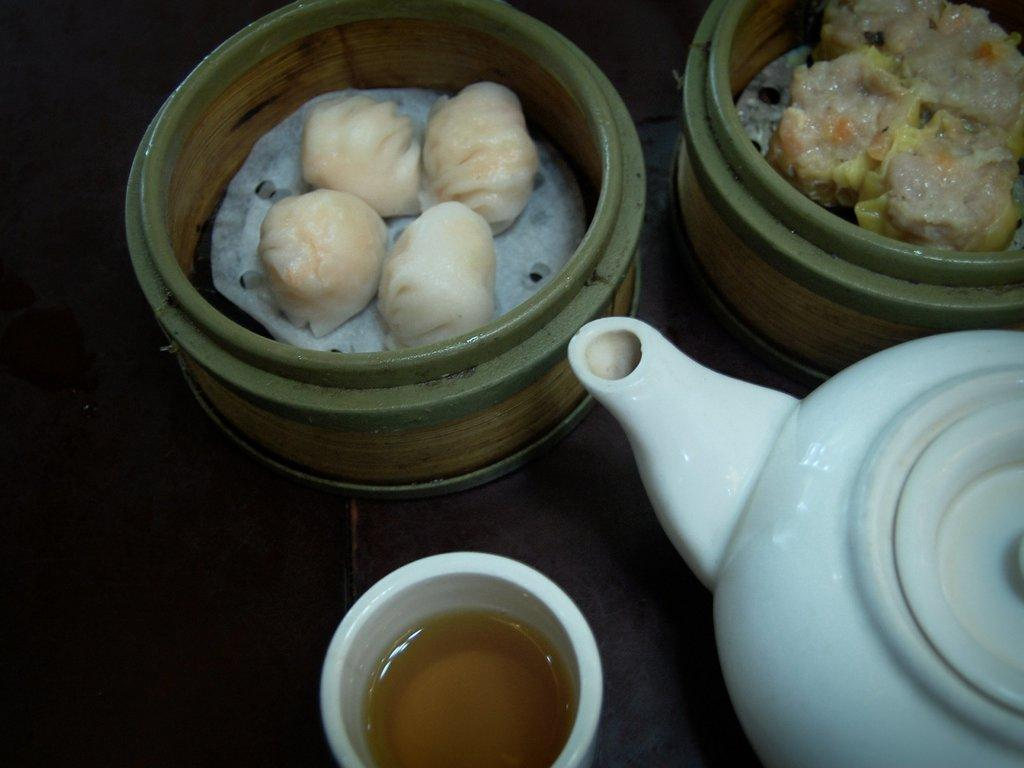What type of containers are visible in the image? There are bowls with food in the image. What is the other beverage-related item in the image? There is a tea pot in the image. What is the third container in the image? There is a glass with a drink in the image. What type of pet can be seen playing with the food in the image? There is no pet present in the image; it only features bowls with food, a tea pot, and a glass with a drink. 